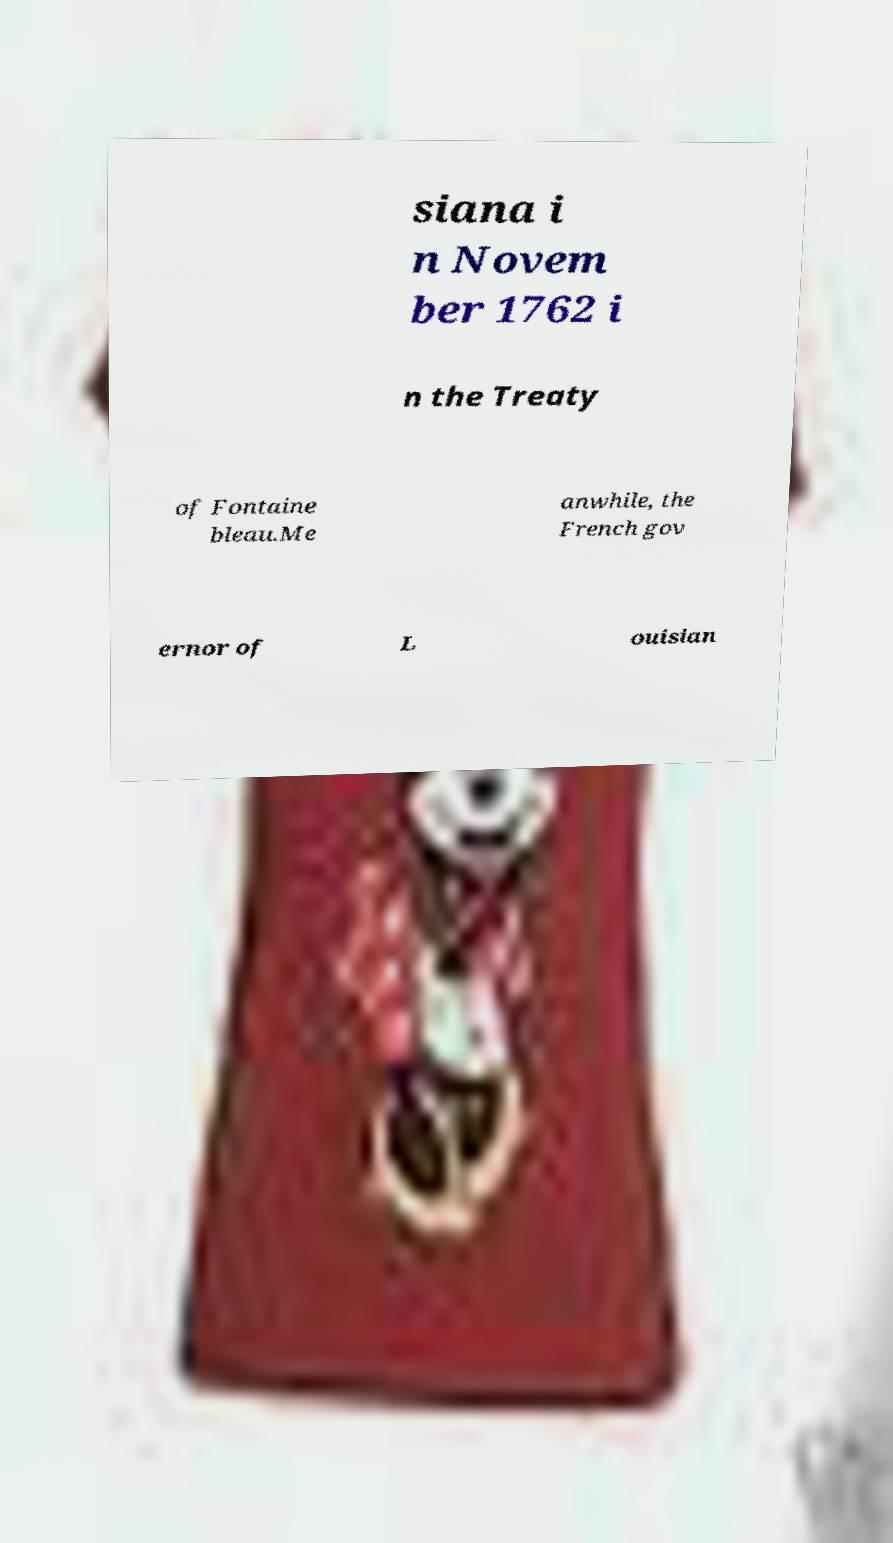Please read and relay the text visible in this image. What does it say? siana i n Novem ber 1762 i n the Treaty of Fontaine bleau.Me anwhile, the French gov ernor of L ouisian 